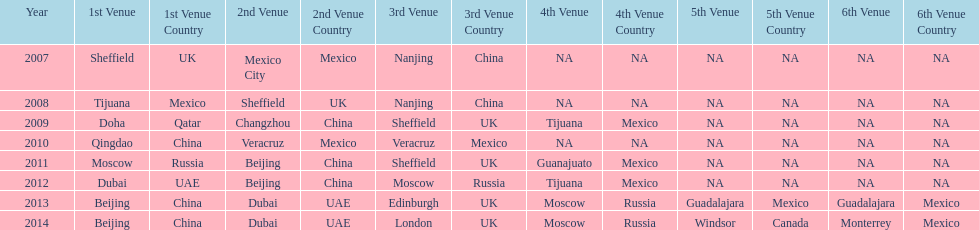In what year was the 3rd venue the same as 2011's 1st venue? 2012. 